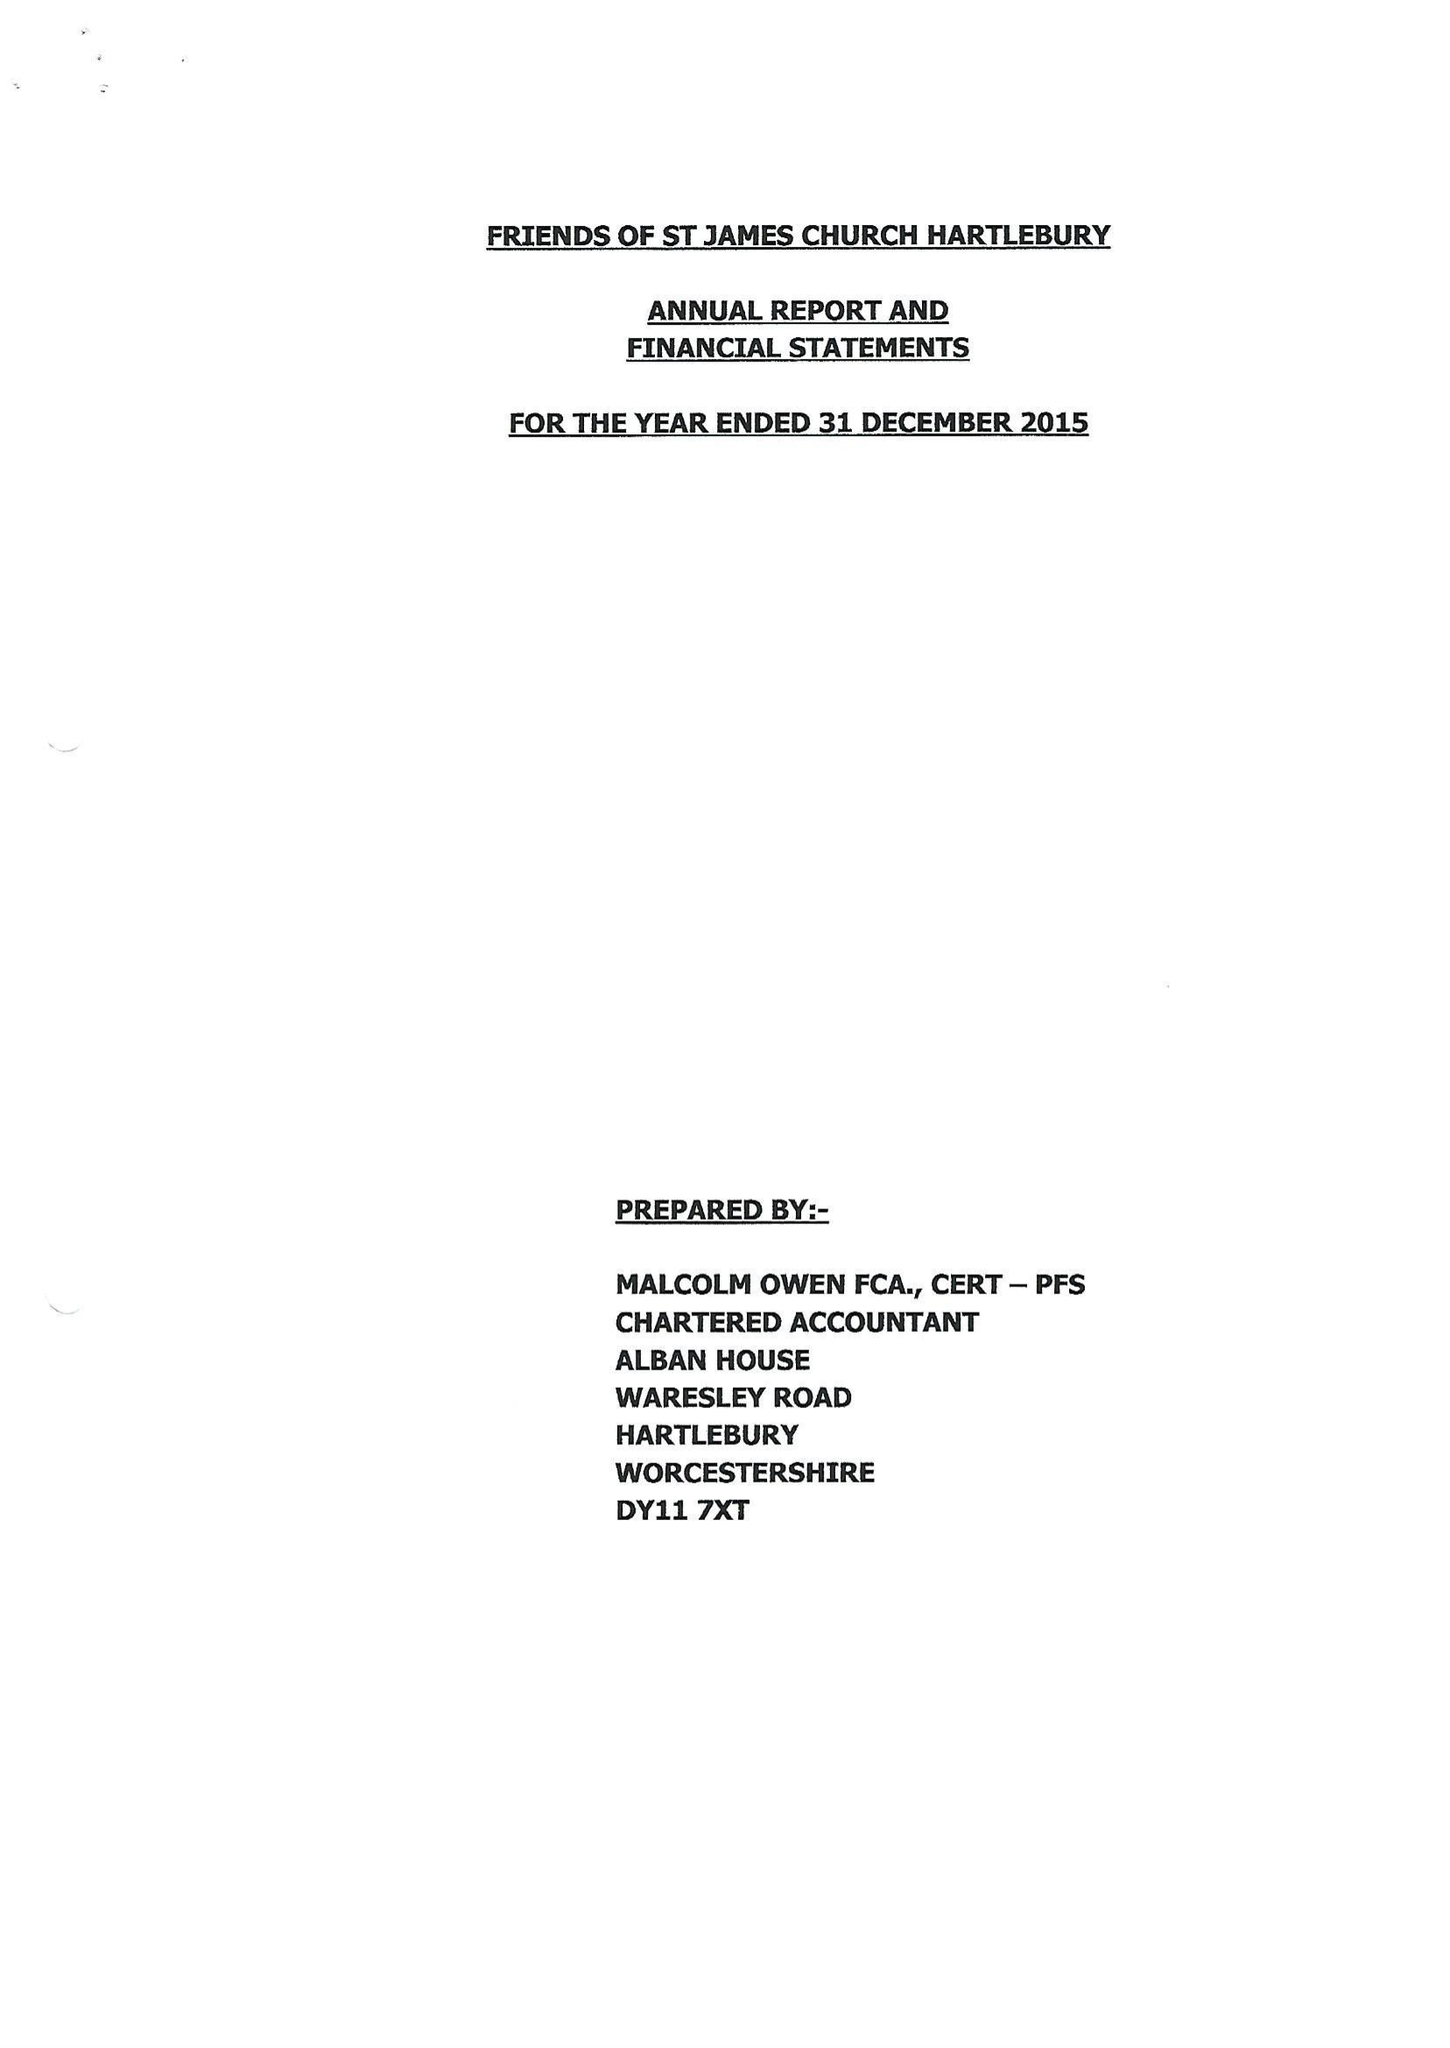What is the value for the report_date?
Answer the question using a single word or phrase. 2015-12-31 